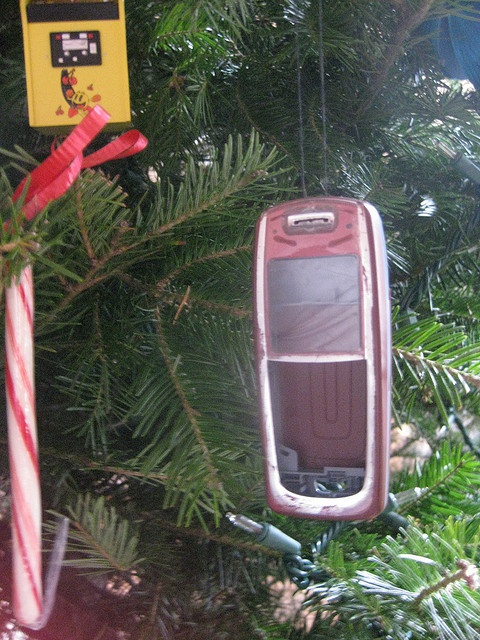Describe the objects in this image and their specific colors. I can see a cell phone in black, gray, darkgray, and lavender tones in this image. 